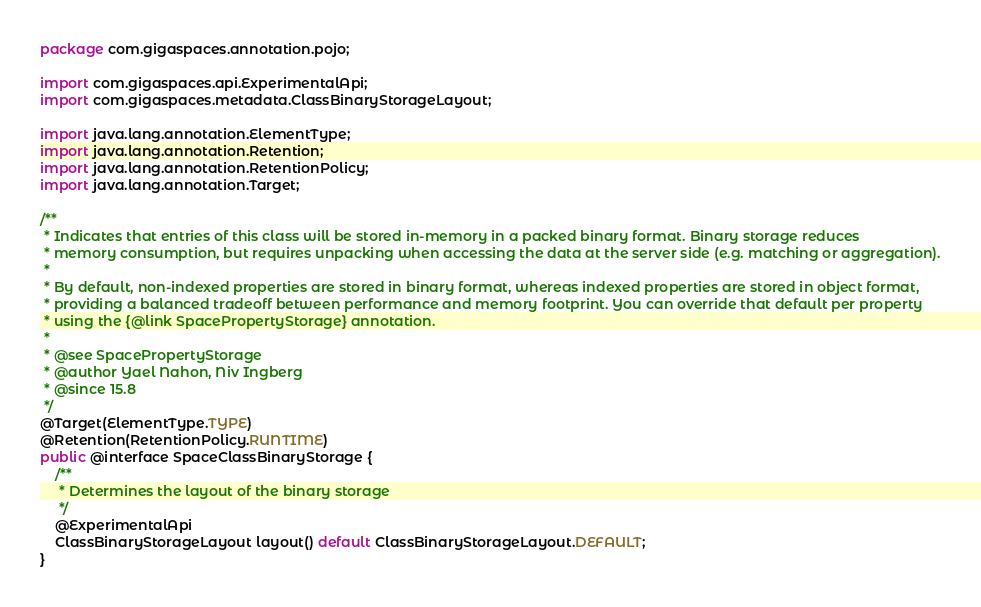Convert code to text. <code><loc_0><loc_0><loc_500><loc_500><_Java_>package com.gigaspaces.annotation.pojo;

import com.gigaspaces.api.ExperimentalApi;
import com.gigaspaces.metadata.ClassBinaryStorageLayout;

import java.lang.annotation.ElementType;
import java.lang.annotation.Retention;
import java.lang.annotation.RetentionPolicy;
import java.lang.annotation.Target;

/**
 * Indicates that entries of this class will be stored in-memory in a packed binary format. Binary storage reduces
 * memory consumption, but requires unpacking when accessing the data at the server side (e.g. matching or aggregation).
 *
 * By default, non-indexed properties are stored in binary format, whereas indexed properties are stored in object format,
 * providing a balanced tradeoff between performance and memory footprint. You can override that default per property
 * using the {@link SpacePropertyStorage} annotation.
 *
 * @see SpacePropertyStorage
 * @author Yael Nahon, Niv Ingberg
 * @since 15.8
 */
@Target(ElementType.TYPE)
@Retention(RetentionPolicy.RUNTIME)
public @interface SpaceClassBinaryStorage {
    /**
     * Determines the layout of the binary storage
     */
    @ExperimentalApi
    ClassBinaryStorageLayout layout() default ClassBinaryStorageLayout.DEFAULT;
}
</code> 